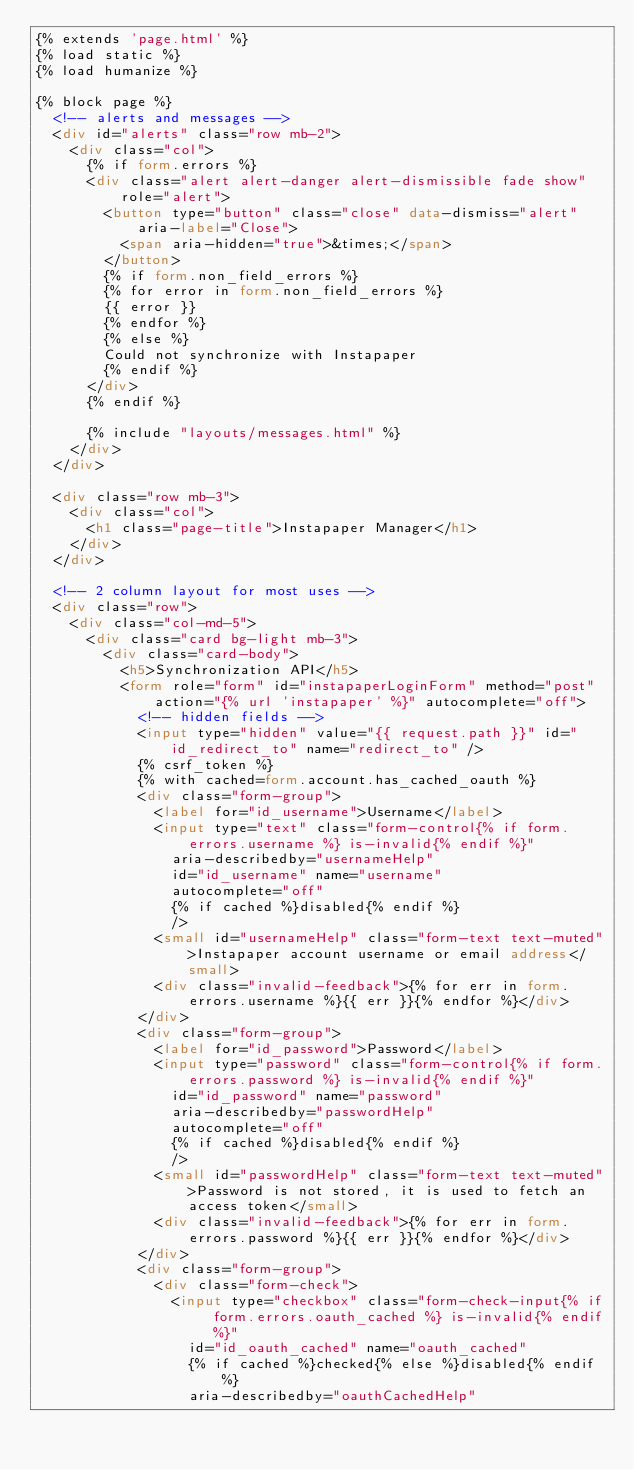Convert code to text. <code><loc_0><loc_0><loc_500><loc_500><_HTML_>{% extends 'page.html' %}
{% load static %}
{% load humanize %}

{% block page %}
  <!-- alerts and messages -->
  <div id="alerts" class="row mb-2">
    <div class="col">
      {% if form.errors %}
      <div class="alert alert-danger alert-dismissible fade show" role="alert">
        <button type="button" class="close" data-dismiss="alert" aria-label="Close">
          <span aria-hidden="true">&times;</span>
        </button>
        {% if form.non_field_errors %}
        {% for error in form.non_field_errors %}
        {{ error }}
        {% endfor %}
        {% else %}
        Could not synchronize with Instapaper
        {% endif %}
      </div>
      {% endif %}

      {% include "layouts/messages.html" %}
    </div>
  </div>

  <div class="row mb-3">
    <div class="col">
      <h1 class="page-title">Instapaper Manager</h1>
    </div>
  </div>

  <!-- 2 column layout for most uses -->
  <div class="row">
    <div class="col-md-5">
      <div class="card bg-light mb-3">
        <div class="card-body">
          <h5>Synchronization API</h5>
          <form role="form" id="instapaperLoginForm" method="post" action="{% url 'instapaper' %}" autocomplete="off">
            <!-- hidden fields -->
            <input type="hidden" value="{{ request.path }}" id="id_redirect_to" name="redirect_to" />
            {% csrf_token %}
            {% with cached=form.account.has_cached_oauth %}
            <div class="form-group">
              <label for="id_username">Username</label>
              <input type="text" class="form-control{% if form.errors.username %} is-invalid{% endif %}"
                aria-describedby="usernameHelp"
                id="id_username" name="username"
                autocomplete="off"
                {% if cached %}disabled{% endif %}
                />
              <small id="usernameHelp" class="form-text text-muted">Instapaper account username or email address</small>
              <div class="invalid-feedback">{% for err in form.errors.username %}{{ err }}{% endfor %}</div>
            </div>
            <div class="form-group">
              <label for="id_password">Password</label>
              <input type="password" class="form-control{% if form.errors.password %} is-invalid{% endif %}"
                id="id_password" name="password"
                aria-describedby="passwordHelp"
                autocomplete="off"
                {% if cached %}disabled{% endif %}
                />
              <small id="passwordHelp" class="form-text text-muted">Password is not stored, it is used to fetch an access token</small>
              <div class="invalid-feedback">{% for err in form.errors.password %}{{ err }}{% endfor %}</div>
            </div>
            <div class="form-group">
              <div class="form-check">
                <input type="checkbox" class="form-check-input{% if form.errors.oauth_cached %} is-invalid{% endif %}"
                  id="id_oauth_cached" name="oauth_cached"
                  {% if cached %}checked{% else %}disabled{% endif %}
                  aria-describedby="oauthCachedHelp"</code> 